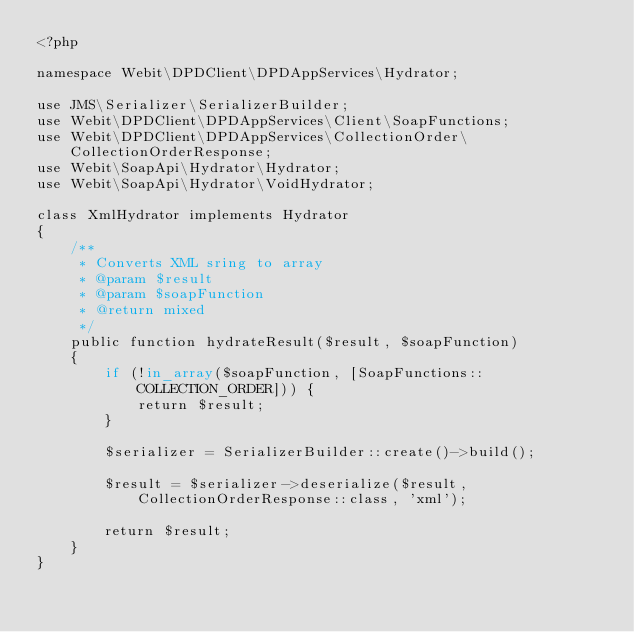Convert code to text. <code><loc_0><loc_0><loc_500><loc_500><_PHP_><?php

namespace Webit\DPDClient\DPDAppServices\Hydrator;

use JMS\Serializer\SerializerBuilder;
use Webit\DPDClient\DPDAppServices\Client\SoapFunctions;
use Webit\DPDClient\DPDAppServices\CollectionOrder\CollectionOrderResponse;
use Webit\SoapApi\Hydrator\Hydrator;
use Webit\SoapApi\Hydrator\VoidHydrator;

class XmlHydrator implements Hydrator
{
    /**
     * Converts XML sring to array
     * @param $result
     * @param $soapFunction
     * @return mixed
     */
    public function hydrateResult($result, $soapFunction)
    {
        if (!in_array($soapFunction, [SoapFunctions::COLLECTION_ORDER])) {
            return $result;
        }

        $serializer = SerializerBuilder::create()->build();

        $result = $serializer->deserialize($result, CollectionOrderResponse::class, 'xml');

        return $result;
    }
}
</code> 